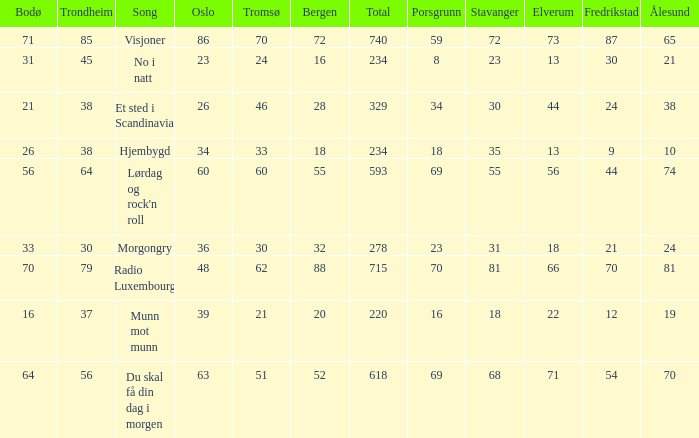When oslo is 48, what is stavanger? 81.0. 